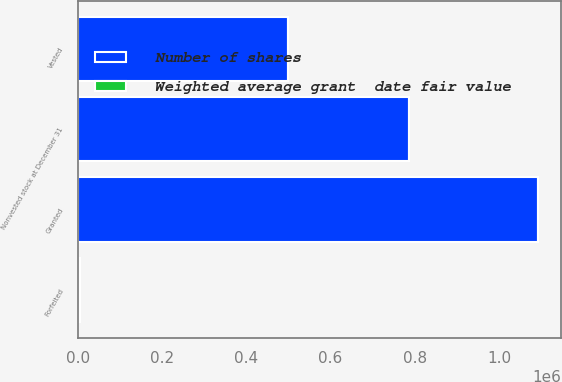Convert chart. <chart><loc_0><loc_0><loc_500><loc_500><stacked_bar_chart><ecel><fcel>Nonvested stock at December 31<fcel>Granted<fcel>Vested<fcel>Forfeited<nl><fcel>Number of shares<fcel>785176<fcel>1.09184e+06<fcel>498540<fcel>5506<nl><fcel>Weighted average grant  date fair value<fcel>87.38<fcel>78.94<fcel>67.83<fcel>71.68<nl></chart> 